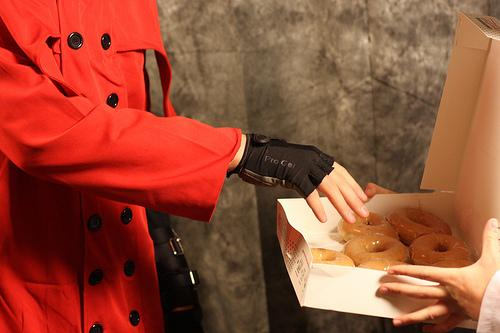What action is the person performing in the image, and what kind of food is involved? The person is grabbing or reaching for some glazed donuts in a box. Tell me what kind of glove is on the person's hand and the text visible on it. The person is wearing a fingerless black glove with text reading "pro cel." What type of accessory is the woman wearing and what color is it? The woman is wearing a small black handbag or purse. How many glazed donuts can be seen in the box? There are seven glazed doughnuts in the box. State the color and material of the wall seen in the background. The wall in the background is brown. Please identify the brand logo present on the donut box. There is a Krispy Kreme logo on the donut box. What is the color of the donut box, and are there any specific markings or text on it? The donut box is white, and there is a Krispy Kreme logo and a receipt on it. In the image, how many total black buttons can be seen on the red coat? There are four black buttons on the red coat. Can you describe the coat worn by the person in the image and any details about its buttons? The person is wearing a large red coat or trench coat, and it has a few black buttons. Mention the position of the hand holding the box and the object it is interacting with. The hand, covered with a black glove, is holding the box close to the glazed donuts inside it, about to pick one up. 